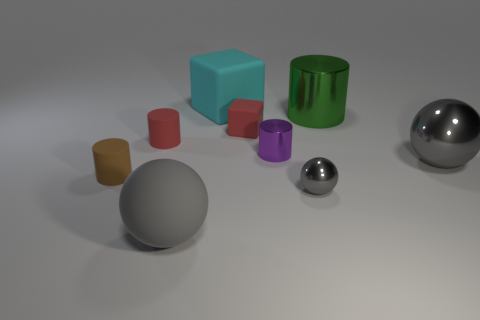Are there any other things that are the same material as the cyan object?
Your answer should be very brief. Yes. What number of metal things are cylinders or big objects?
Keep it short and to the point. 3. There is a gray sphere that is behind the small rubber object that is to the left of the red matte cylinder; what is its size?
Provide a short and direct response. Large. There is a small thing that is the same color as the rubber sphere; what is its material?
Your response must be concise. Metal. There is a small red rubber thing on the right side of the large ball that is left of the tiny purple metal cylinder; are there any tiny gray balls to the right of it?
Your answer should be compact. Yes. Does the green cylinder behind the small metallic sphere have the same material as the big ball to the right of the big cyan thing?
Offer a very short reply. Yes. What number of objects are small brown cubes or things that are to the right of the large gray rubber ball?
Provide a succinct answer. 6. How many other rubber objects have the same shape as the tiny purple thing?
Ensure brevity in your answer.  2. There is a block that is the same size as the brown rubber thing; what is it made of?
Offer a terse response. Rubber. How big is the cylinder that is in front of the gray shiny object to the right of the metal thing in front of the tiny brown matte cylinder?
Your answer should be compact. Small. 